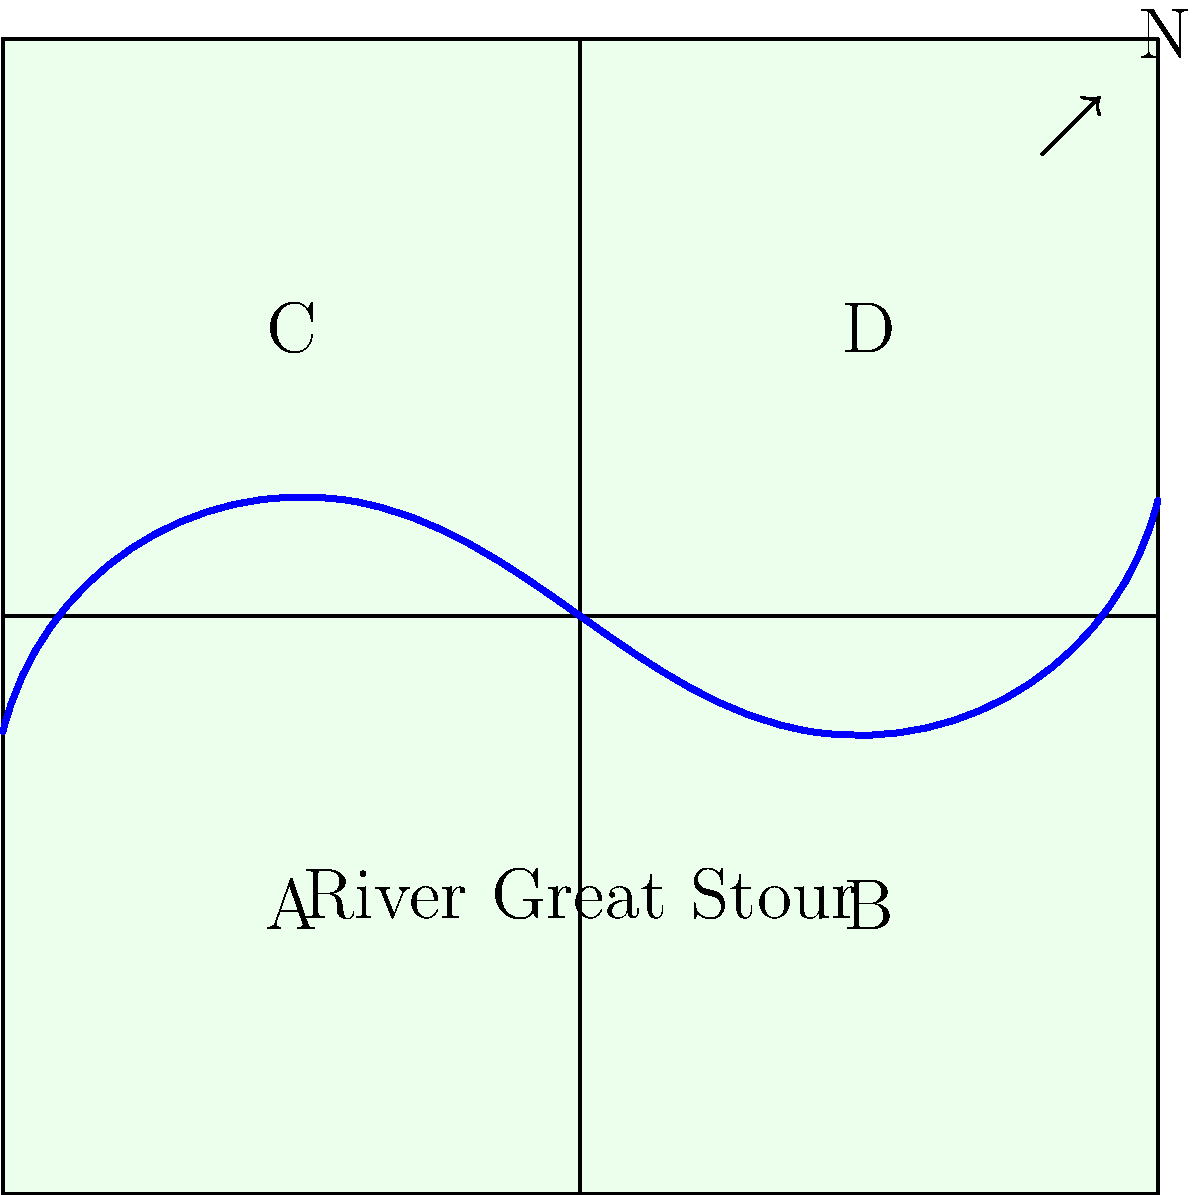Based on the simplified map of Canterbury's electoral wards shown above, which ward is likely to include the city center, considering the path of the River Great Stour and the typical layout of historical English cities? To determine which ward is likely to include Canterbury's city center, let's consider the following steps:

1. Observe the river: The River Great Stour is shown flowing through the map, which is a key geographical feature of Canterbury.

2. Historical context: Many historical English cities developed around rivers, often with the city center located near a river crossing.

3. River path: The river enters the map from the west (left) and flows towards the east (right), passing through wards A and B.

4. Ward location: 
   - Ward A is in the southwest
   - Ward B is in the southeast
   - Ward C is in the northwest
   - Ward D is in the northeast

5. City center likelihood: Given that the river flows through the southern part of the map and historical city centers often developed near rivers, the city center is more likely to be in either Ward A or Ward B.

6. Final deduction: Ward A is more centrally located with respect to the river's path and the other wards. It's positioned where the river enters the mapped area, which is often a strategic location for historical settlements.

Therefore, Ward A is the most likely location for Canterbury's city center based on this simplified map and typical patterns of English city development.
Answer: Ward A 